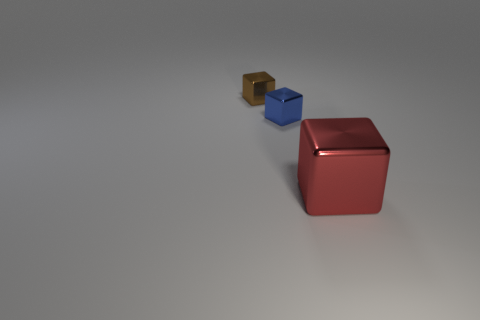Is the number of brown blocks in front of the large object the same as the number of blue objects to the right of the brown block?
Offer a very short reply. No. There is a blue shiny block; what number of small metal objects are in front of it?
Your answer should be very brief. 0. What number of objects are red cubes or blocks?
Your answer should be compact. 3. How many other cubes are the same size as the brown cube?
Offer a terse response. 1. The small thing behind the small metal block on the right side of the brown metallic thing is what shape?
Offer a terse response. Cube. Is the number of large metal objects less than the number of small cubes?
Your answer should be very brief. Yes. There is a small thing that is in front of the brown object; what color is it?
Make the answer very short. Blue. The large thing that is the same material as the brown block is what shape?
Provide a short and direct response. Cube. There is a tiny metal cube that is behind the small blue metal block; how many red blocks are left of it?
Provide a short and direct response. 0. How many shiny cubes are both in front of the small brown shiny object and behind the big cube?
Offer a terse response. 1. 